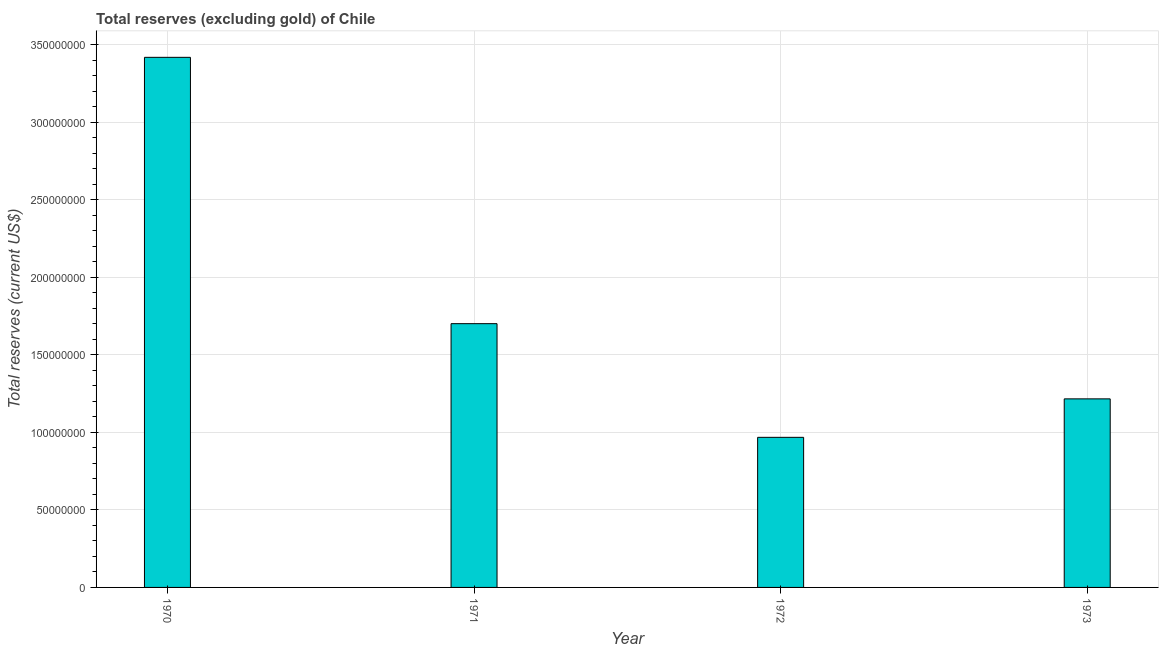Does the graph contain any zero values?
Make the answer very short. No. What is the title of the graph?
Give a very brief answer. Total reserves (excluding gold) of Chile. What is the label or title of the Y-axis?
Keep it short and to the point. Total reserves (current US$). What is the total reserves (excluding gold) in 1970?
Offer a very short reply. 3.42e+08. Across all years, what is the maximum total reserves (excluding gold)?
Keep it short and to the point. 3.42e+08. Across all years, what is the minimum total reserves (excluding gold)?
Offer a very short reply. 9.68e+07. In which year was the total reserves (excluding gold) maximum?
Offer a terse response. 1970. In which year was the total reserves (excluding gold) minimum?
Make the answer very short. 1972. What is the sum of the total reserves (excluding gold)?
Give a very brief answer. 7.30e+08. What is the difference between the total reserves (excluding gold) in 1970 and 1972?
Offer a terse response. 2.45e+08. What is the average total reserves (excluding gold) per year?
Keep it short and to the point. 1.83e+08. What is the median total reserves (excluding gold)?
Make the answer very short. 1.46e+08. Do a majority of the years between 1973 and 1971 (inclusive) have total reserves (excluding gold) greater than 100000000 US$?
Give a very brief answer. Yes. What is the ratio of the total reserves (excluding gold) in 1972 to that in 1973?
Your answer should be very brief. 0.8. Is the total reserves (excluding gold) in 1970 less than that in 1972?
Your answer should be very brief. No. Is the difference between the total reserves (excluding gold) in 1971 and 1972 greater than the difference between any two years?
Provide a succinct answer. No. What is the difference between the highest and the second highest total reserves (excluding gold)?
Your response must be concise. 1.72e+08. Is the sum of the total reserves (excluding gold) in 1970 and 1972 greater than the maximum total reserves (excluding gold) across all years?
Make the answer very short. Yes. What is the difference between the highest and the lowest total reserves (excluding gold)?
Your answer should be very brief. 2.45e+08. How many bars are there?
Keep it short and to the point. 4. Are all the bars in the graph horizontal?
Ensure brevity in your answer.  No. What is the Total reserves (current US$) in 1970?
Keep it short and to the point. 3.42e+08. What is the Total reserves (current US$) of 1971?
Your answer should be compact. 1.70e+08. What is the Total reserves (current US$) in 1972?
Your response must be concise. 9.68e+07. What is the Total reserves (current US$) of 1973?
Provide a succinct answer. 1.22e+08. What is the difference between the Total reserves (current US$) in 1970 and 1971?
Your answer should be very brief. 1.72e+08. What is the difference between the Total reserves (current US$) in 1970 and 1972?
Your response must be concise. 2.45e+08. What is the difference between the Total reserves (current US$) in 1970 and 1973?
Your response must be concise. 2.20e+08. What is the difference between the Total reserves (current US$) in 1971 and 1972?
Make the answer very short. 7.33e+07. What is the difference between the Total reserves (current US$) in 1971 and 1973?
Ensure brevity in your answer.  4.85e+07. What is the difference between the Total reserves (current US$) in 1972 and 1973?
Offer a very short reply. -2.48e+07. What is the ratio of the Total reserves (current US$) in 1970 to that in 1971?
Give a very brief answer. 2.01. What is the ratio of the Total reserves (current US$) in 1970 to that in 1972?
Your answer should be compact. 3.53. What is the ratio of the Total reserves (current US$) in 1970 to that in 1973?
Your response must be concise. 2.81. What is the ratio of the Total reserves (current US$) in 1971 to that in 1972?
Offer a very short reply. 1.76. What is the ratio of the Total reserves (current US$) in 1971 to that in 1973?
Ensure brevity in your answer.  1.4. What is the ratio of the Total reserves (current US$) in 1972 to that in 1973?
Your response must be concise. 0.8. 